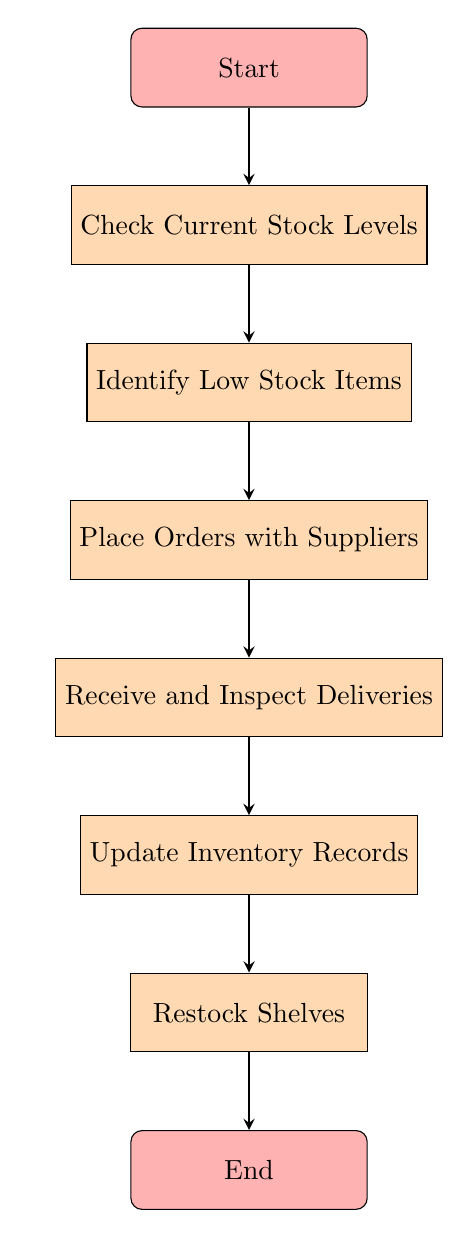What is the first step in the flow chart? The first step is indicated by the "Start" node at the top of the flow chart, which marks the beginning of the inventory management process.
Answer: Start How many nodes are present in the diagram? By counting the distinct labeled boxes in the diagram, there are a total of seven nodes, each representing a step in managing inventory.
Answer: 7 What happens after checking current stock levels? After the "Check Current Stock Levels" node, the flow progresses to the next node labeled "Identify Low Stock Items." This shows that identifying low stock items follows the stock level check.
Answer: Identify Low Stock Items What is the last step in the inventory management process? The last step is indicated by the "End" node, which signifies the completion of the inventory management process after all prior steps have been executed.
Answer: End Which node directly follows receiving and inspecting deliveries? The node that follows the "Receive and Inspect Deliveries" is the "Update Inventory Records" node, indicating this is the next action to take after checking the deliveries.
Answer: Update Inventory Records What is the relationship between identifying low stock items and placing orders with suppliers? The relationship is sequential, where identifying low stock items leads directly into the next action of placing orders with suppliers, suggesting that the identification of stock needs drives the ordering process.
Answer: Place Orders with Suppliers What is the primary purpose of the "Update Inventory Records" node? The primary purpose of the "Update Inventory Records" is to document the changes in stock, ensuring that inventory records reflect the current stock levels after new items have been received.
Answer: Update Inventory Records Which two nodes are connected directly in a sequence after placing orders with suppliers? The two connected nodes that follow are "Receive and Inspect Deliveries" and "Update Inventory Records," showing the flow from placing orders to handling deliveries.
Answer: Receive and Inspect Deliveries, Update Inventory Records 